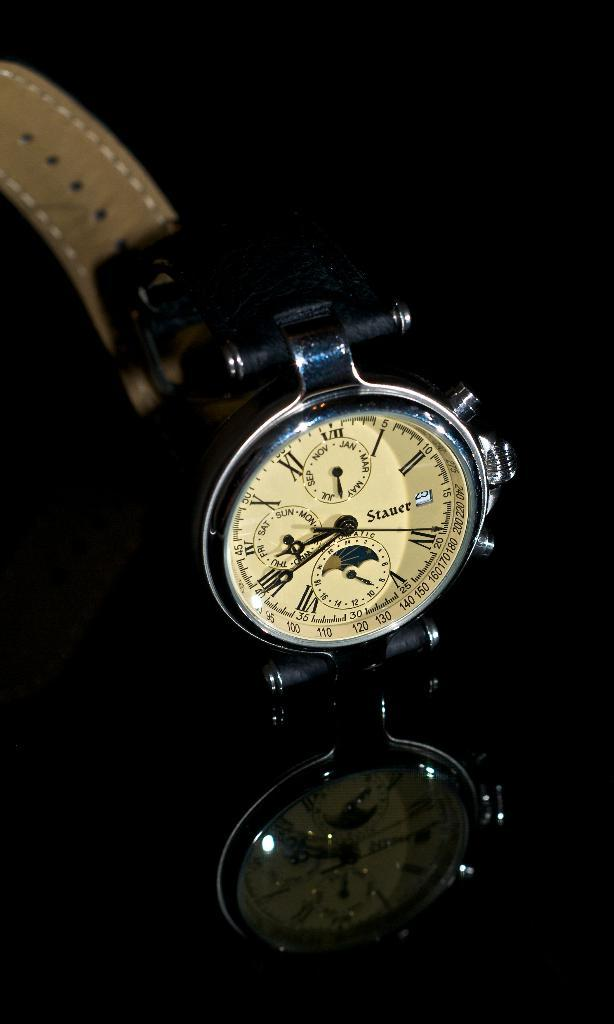<image>
Describe the image concisely. A watch has "Stauer" printed on the face. 